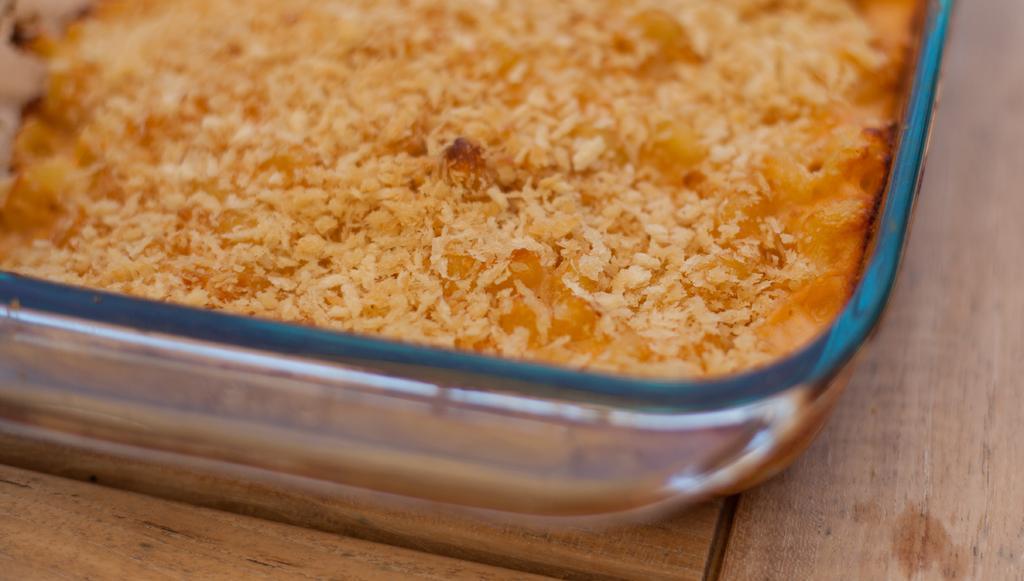How would you summarize this image in a sentence or two? In this image we can see a bowl containing food placed on the table. 